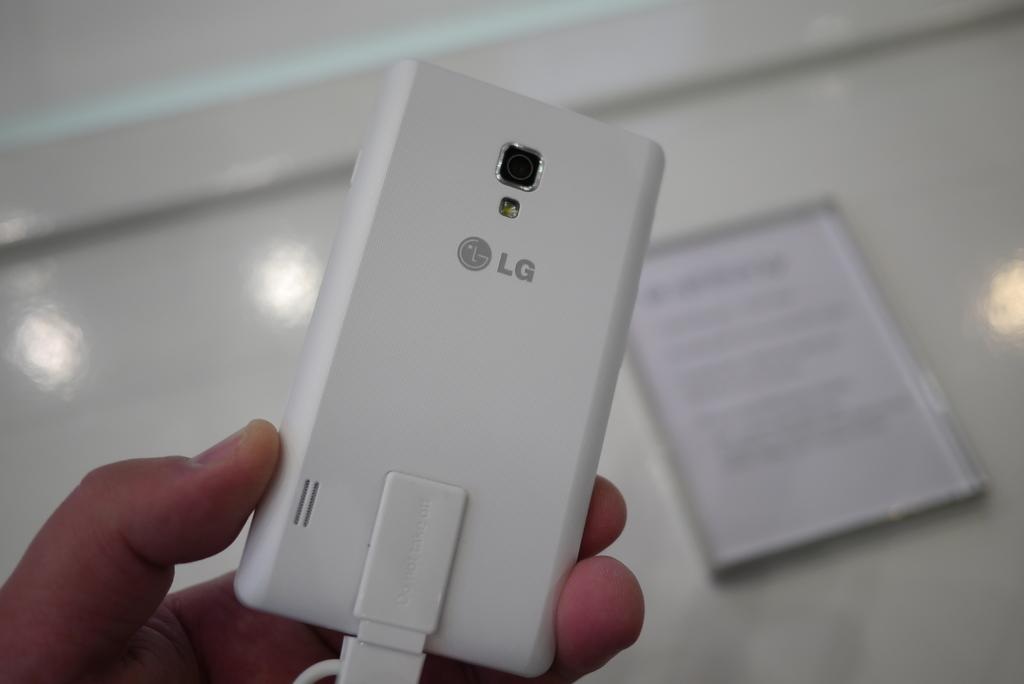<image>
Render a clear and concise summary of the photo. Someone holds a white LG phone in their hand. 